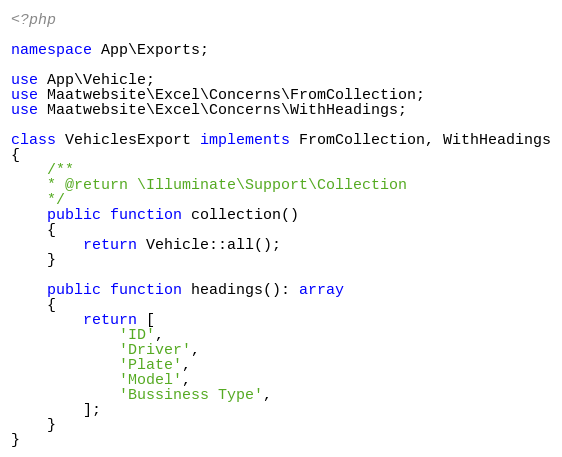Convert code to text. <code><loc_0><loc_0><loc_500><loc_500><_PHP_><?php

namespace App\Exports;

use App\Vehicle;
use Maatwebsite\Excel\Concerns\FromCollection;
use Maatwebsite\Excel\Concerns\WithHeadings;

class VehiclesExport implements FromCollection, WithHeadings
{
    /**
    * @return \Illuminate\Support\Collection
    */
    public function collection()
    {
        return Vehicle::all();
    }

    public function headings(): array
    {
        return [
            'ID',
            'Driver',
            'Plate',
            'Model',
            'Bussiness Type',
        ];
    }
}
</code> 